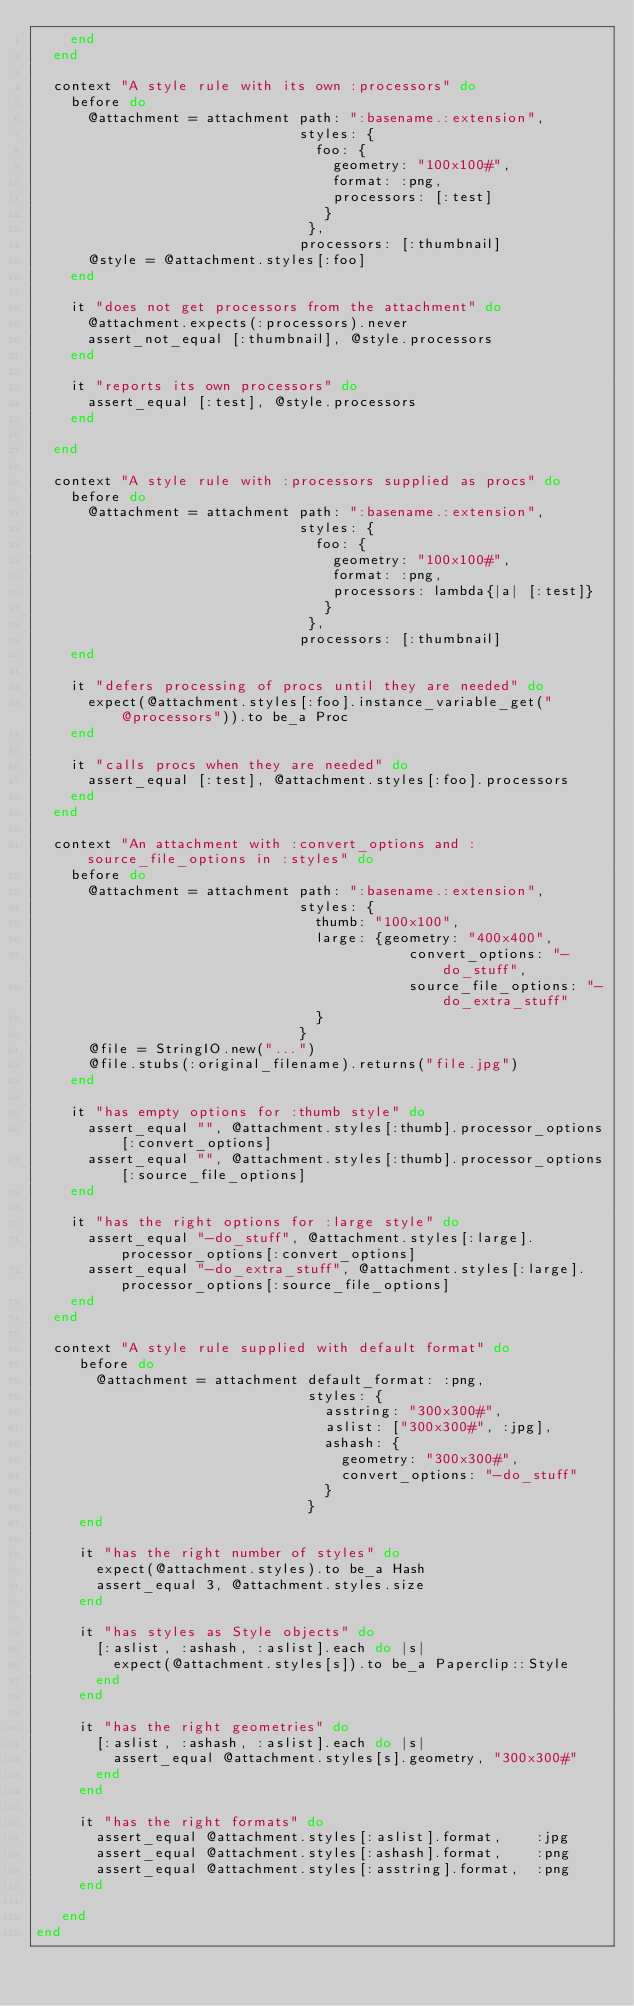Convert code to text. <code><loc_0><loc_0><loc_500><loc_500><_Ruby_>    end
  end

  context "A style rule with its own :processors" do
    before do
      @attachment = attachment path: ":basename.:extension",
                               styles: {
                                 foo: {
                                   geometry: "100x100#",
                                   format: :png,
                                   processors: [:test]
                                  }
                                },
                               processors: [:thumbnail]
      @style = @attachment.styles[:foo]
    end

    it "does not get processors from the attachment" do
      @attachment.expects(:processors).never
      assert_not_equal [:thumbnail], @style.processors
    end

    it "reports its own processors" do
      assert_equal [:test], @style.processors
    end

  end

  context "A style rule with :processors supplied as procs" do
    before do
      @attachment = attachment path: ":basename.:extension",
                               styles: {
                                 foo: {
                                   geometry: "100x100#",
                                   format: :png,
                                   processors: lambda{|a| [:test]}
                                  }
                                },
                               processors: [:thumbnail]
    end

    it "defers processing of procs until they are needed" do
      expect(@attachment.styles[:foo].instance_variable_get("@processors")).to be_a Proc
    end

    it "calls procs when they are needed" do
      assert_equal [:test], @attachment.styles[:foo].processors
    end
  end

  context "An attachment with :convert_options and :source_file_options in :styles" do
    before do
      @attachment = attachment path: ":basename.:extension",
                               styles: {
                                 thumb: "100x100",
                                 large: {geometry: "400x400",
                                            convert_options: "-do_stuff",
                                            source_file_options: "-do_extra_stuff"
                                 }
                               }
      @file = StringIO.new("...")
      @file.stubs(:original_filename).returns("file.jpg")
    end

    it "has empty options for :thumb style" do
      assert_equal "", @attachment.styles[:thumb].processor_options[:convert_options]
      assert_equal "", @attachment.styles[:thumb].processor_options[:source_file_options]
    end

    it "has the right options for :large style" do
      assert_equal "-do_stuff", @attachment.styles[:large].processor_options[:convert_options]
      assert_equal "-do_extra_stuff", @attachment.styles[:large].processor_options[:source_file_options]
    end
  end

  context "A style rule supplied with default format" do
     before do
       @attachment = attachment default_format: :png,
                                styles: {
                                  asstring: "300x300#",
                                  aslist: ["300x300#", :jpg],
                                  ashash: {
                                    geometry: "300x300#",
                                    convert_options: "-do_stuff"
                                  }
                                }
     end

     it "has the right number of styles" do
       expect(@attachment.styles).to be_a Hash
       assert_equal 3, @attachment.styles.size
     end

     it "has styles as Style objects" do
       [:aslist, :ashash, :aslist].each do |s|
         expect(@attachment.styles[s]).to be_a Paperclip::Style
       end
     end

     it "has the right geometries" do
       [:aslist, :ashash, :aslist].each do |s|
         assert_equal @attachment.styles[s].geometry, "300x300#"
       end
     end

     it "has the right formats" do
       assert_equal @attachment.styles[:aslist].format,    :jpg
       assert_equal @attachment.styles[:ashash].format,    :png
       assert_equal @attachment.styles[:asstring].format,  :png
     end

   end
end
</code> 